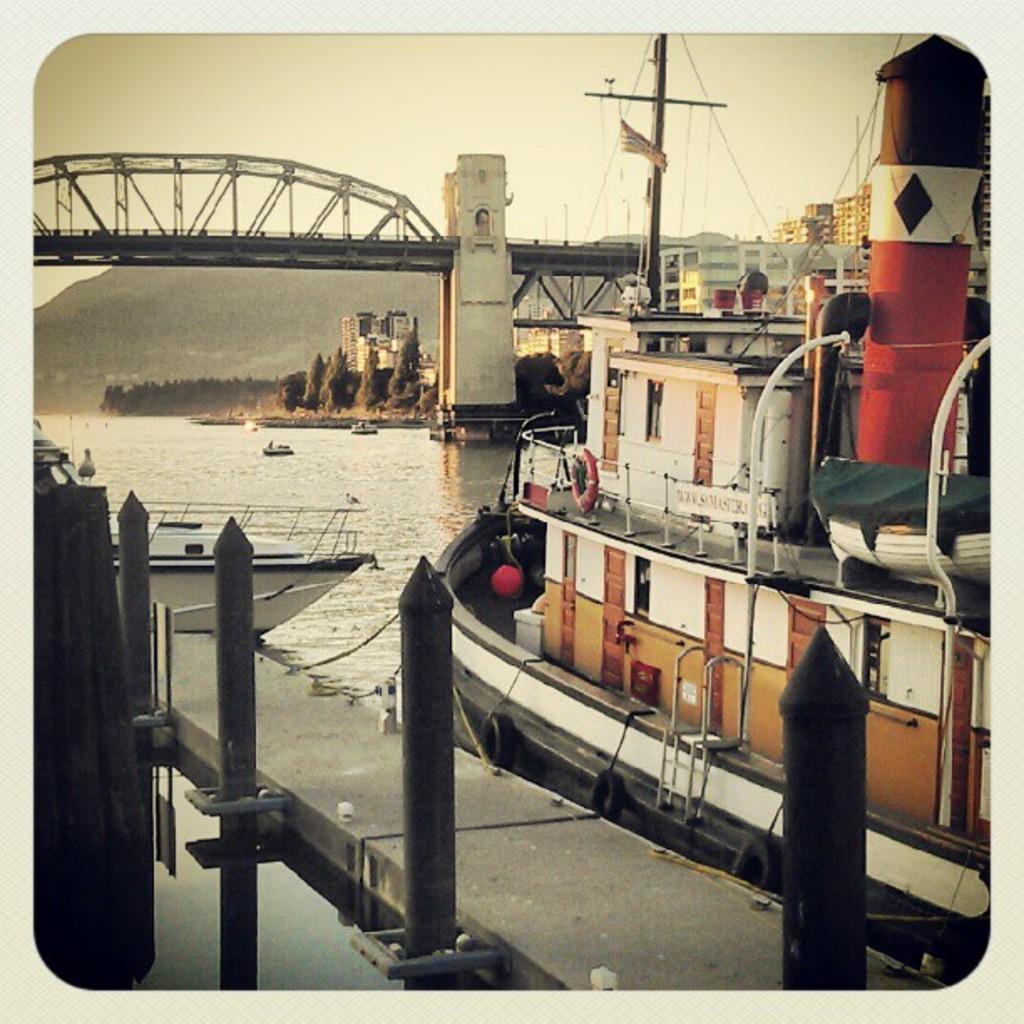Please provide a concise description of this image. This is an edited image , where there are boats on the water , buildings, trees, bridge, flag with a pole ,hills , and in the background there is sky. 